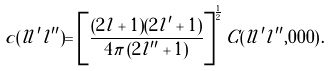Convert formula to latex. <formula><loc_0><loc_0><loc_500><loc_500>c ( l l ^ { \prime } l ^ { \prime \prime } ) = \left [ \frac { ( 2 l + 1 ) ( 2 l ^ { \prime } + 1 ) } { 4 \pi \, ( 2 l ^ { \prime \prime } + 1 ) } \right ] ^ { \frac { 1 } { 2 } } C ( l l ^ { \prime } l ^ { \prime \prime } , 0 0 0 ) \, .</formula> 